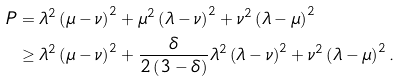Convert formula to latex. <formula><loc_0><loc_0><loc_500><loc_500>P & = \lambda ^ { 2 } \left ( \mu - \nu \right ) ^ { 2 } + \mu ^ { 2 } \left ( \lambda - \nu \right ) ^ { 2 } + \nu ^ { 2 } \left ( \lambda - \mu \right ) ^ { 2 } \\ & \geq \lambda ^ { 2 } \left ( \mu - \nu \right ) ^ { 2 } + \frac { \delta } { 2 \left ( 3 - \delta \right ) } \lambda ^ { 2 } \left ( \lambda - \nu \right ) ^ { 2 } + \nu ^ { 2 } \left ( \lambda - \mu \right ) ^ { 2 } .</formula> 